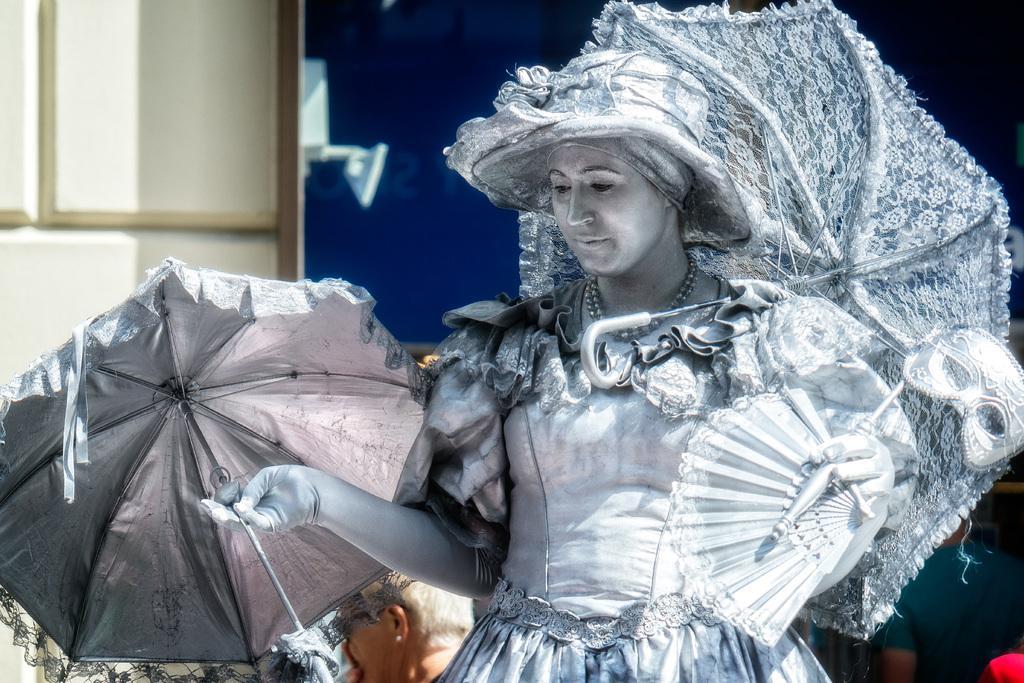Can you describe this image briefly? In this image we can see a person wearing a costume and holding umbrellas and a mask. At the bottom there are people. In the background there is a wall. 